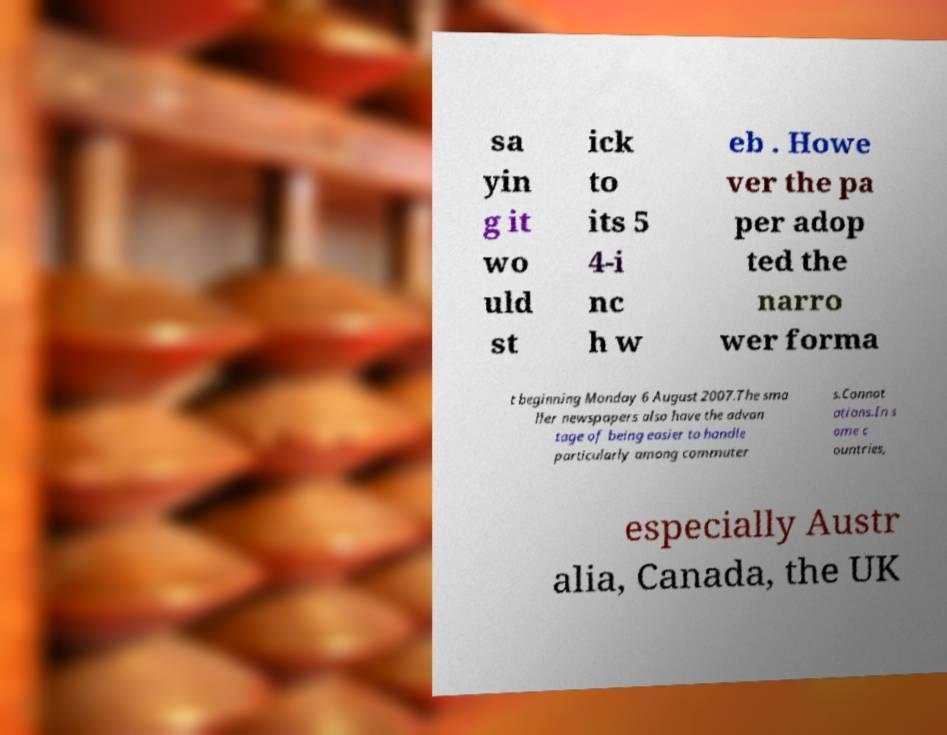Can you accurately transcribe the text from the provided image for me? sa yin g it wo uld st ick to its 5 4-i nc h w eb . Howe ver the pa per adop ted the narro wer forma t beginning Monday 6 August 2007.The sma ller newspapers also have the advan tage of being easier to handle particularly among commuter s.Connot ations.In s ome c ountries, especially Austr alia, Canada, the UK 